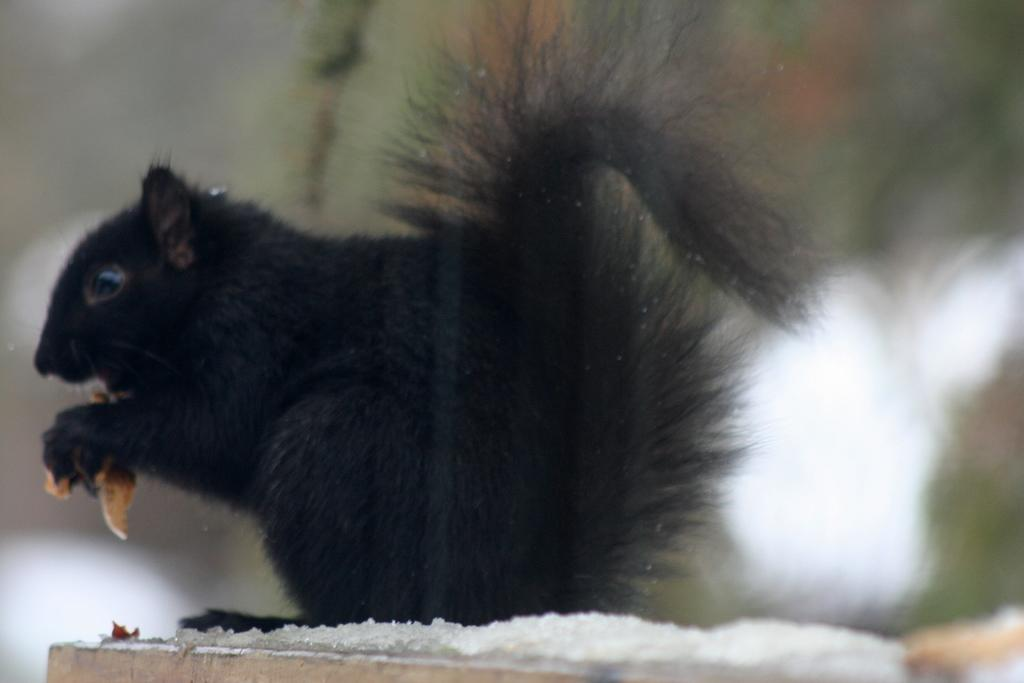What type of animal is in the image? There is a black color rat in the image. What is the rat doing in the image? The rat is on a surface and holding something in its hands. Can you describe the background of the image? The background of the image is not clear. What type of cave can be seen in the background of the image? There is no cave present in the image; the background is not clear. How does the rat use humor to interact with the net in the image? There is no net present in the image, and the rat does not display any humor in its actions. 